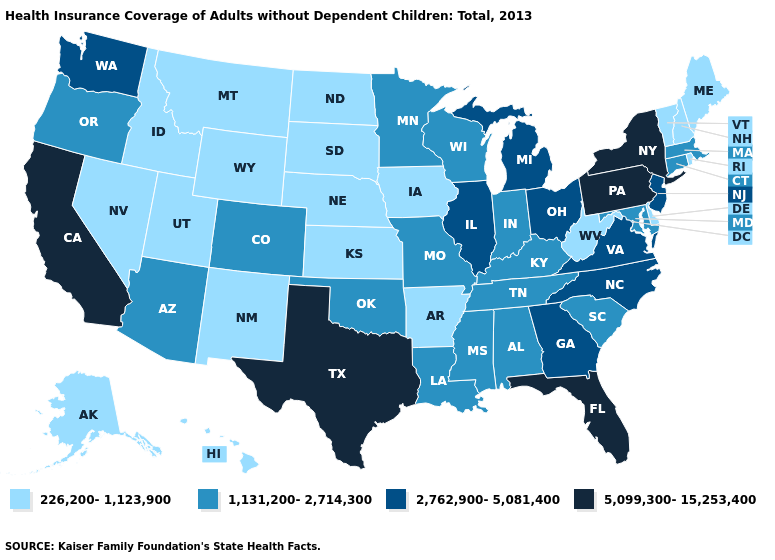Does Arizona have the highest value in the West?
Quick response, please. No. Name the states that have a value in the range 2,762,900-5,081,400?
Quick response, please. Georgia, Illinois, Michigan, New Jersey, North Carolina, Ohio, Virginia, Washington. What is the lowest value in the MidWest?
Keep it brief. 226,200-1,123,900. What is the value of Pennsylvania?
Concise answer only. 5,099,300-15,253,400. Does New York have the highest value in the USA?
Answer briefly. Yes. What is the value of Tennessee?
Answer briefly. 1,131,200-2,714,300. Name the states that have a value in the range 2,762,900-5,081,400?
Concise answer only. Georgia, Illinois, Michigan, New Jersey, North Carolina, Ohio, Virginia, Washington. Does California have a higher value than New York?
Concise answer only. No. Name the states that have a value in the range 1,131,200-2,714,300?
Give a very brief answer. Alabama, Arizona, Colorado, Connecticut, Indiana, Kentucky, Louisiana, Maryland, Massachusetts, Minnesota, Mississippi, Missouri, Oklahoma, Oregon, South Carolina, Tennessee, Wisconsin. What is the value of South Dakota?
Give a very brief answer. 226,200-1,123,900. Name the states that have a value in the range 5,099,300-15,253,400?
Keep it brief. California, Florida, New York, Pennsylvania, Texas. Does Pennsylvania have the lowest value in the USA?
Concise answer only. No. What is the value of Alaska?
Concise answer only. 226,200-1,123,900. Which states have the lowest value in the West?
Short answer required. Alaska, Hawaii, Idaho, Montana, Nevada, New Mexico, Utah, Wyoming. 